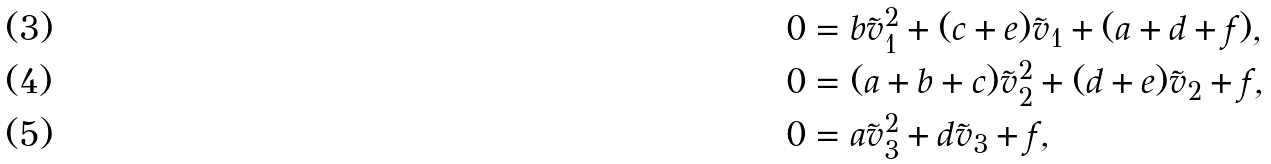<formula> <loc_0><loc_0><loc_500><loc_500>0 & = b \tilde { v } _ { 1 } ^ { 2 } + ( c + e ) \tilde { v } _ { 1 } + ( a + d + f ) , \\ 0 & = ( a + b + c ) \tilde { v } _ { 2 } ^ { 2 } + ( d + e ) \tilde { v } _ { 2 } + f , \\ 0 & = a \tilde { v } _ { 3 } ^ { 2 } + d \tilde { v } _ { 3 } + f ,</formula> 